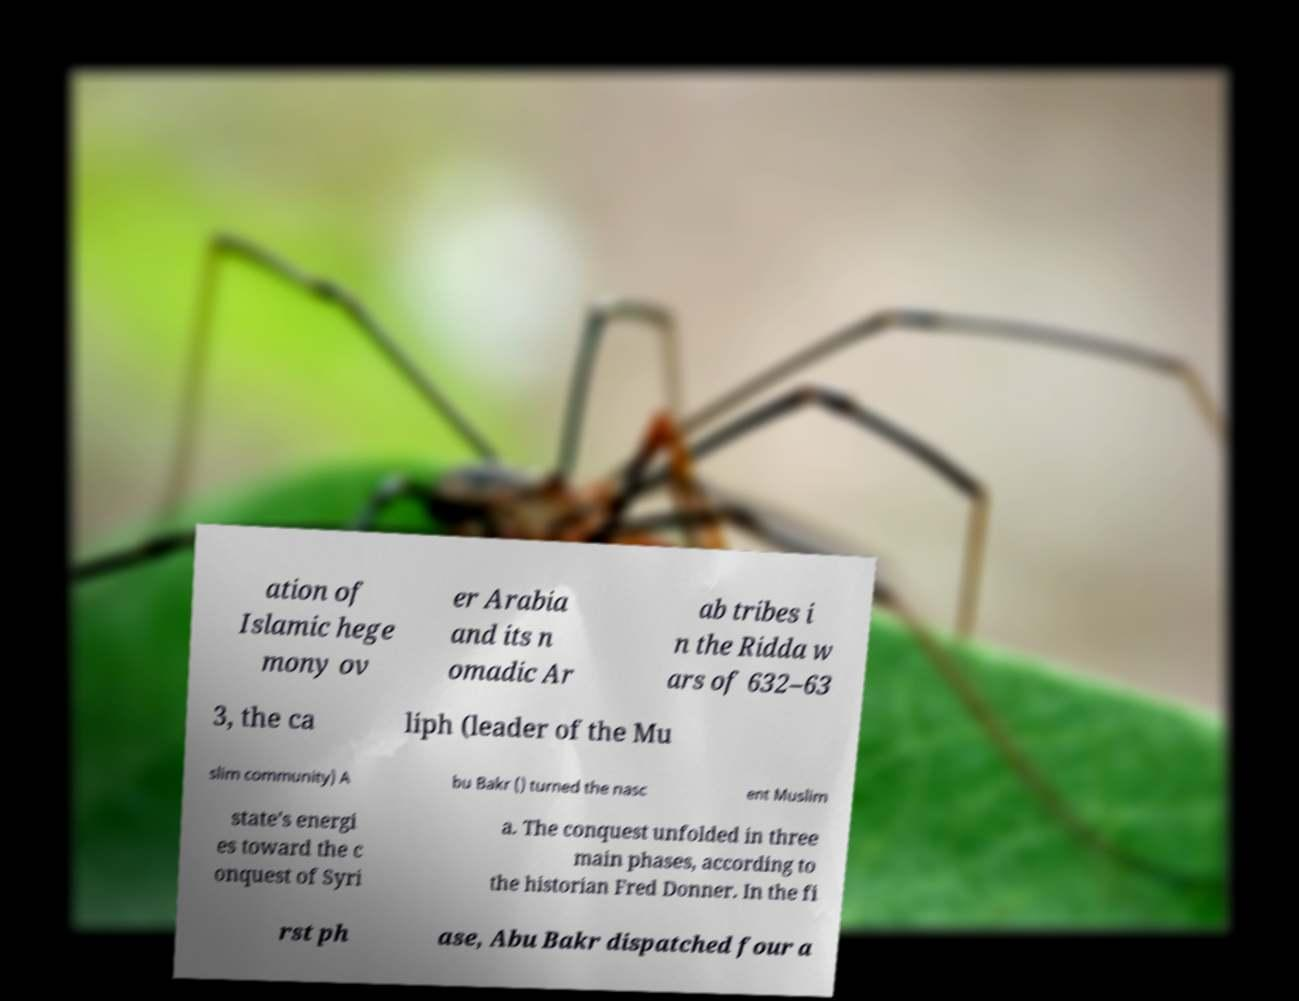Can you accurately transcribe the text from the provided image for me? ation of Islamic hege mony ov er Arabia and its n omadic Ar ab tribes i n the Ridda w ars of 632–63 3, the ca liph (leader of the Mu slim community) A bu Bakr () turned the nasc ent Muslim state's energi es toward the c onquest of Syri a. The conquest unfolded in three main phases, according to the historian Fred Donner. In the fi rst ph ase, Abu Bakr dispatched four a 